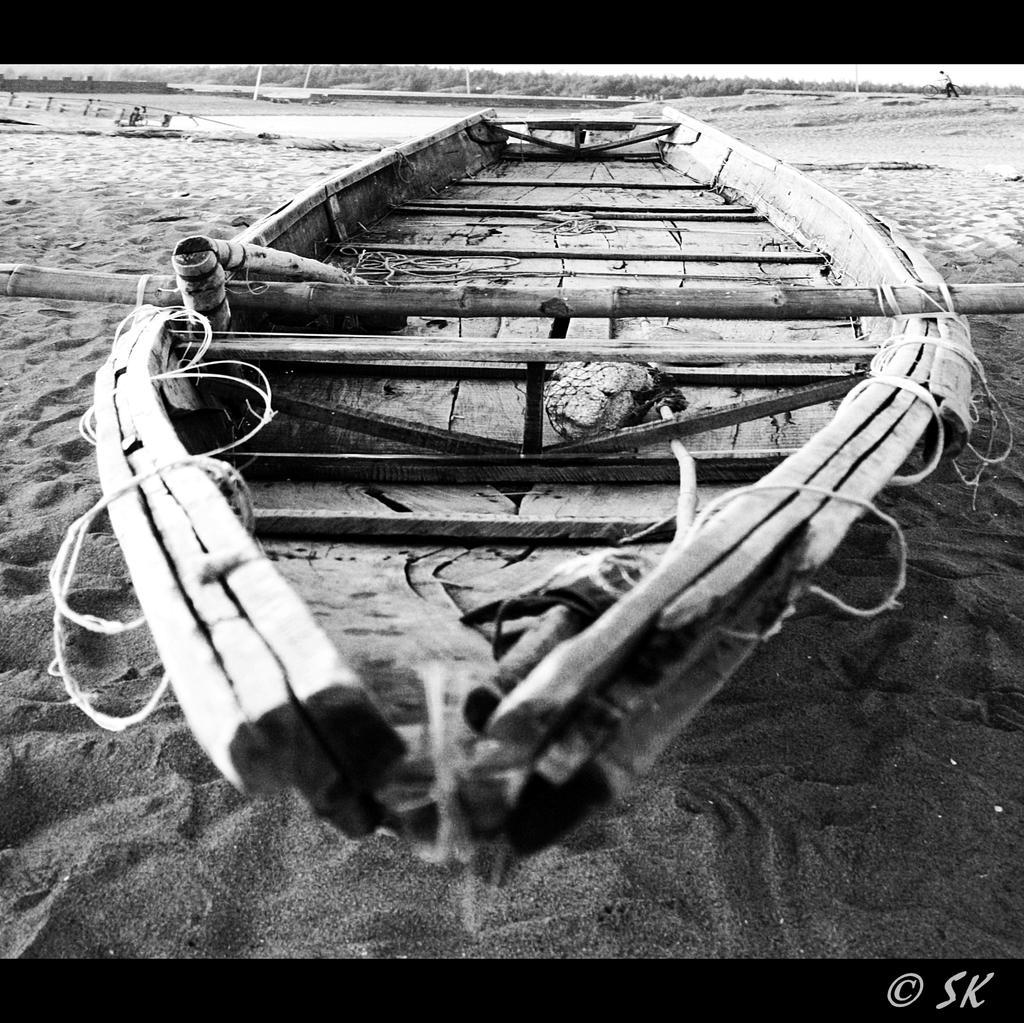In one or two sentences, can you explain what this image depicts? In this image we can see a boat placed on the sand, sea shore, trees and a person. 